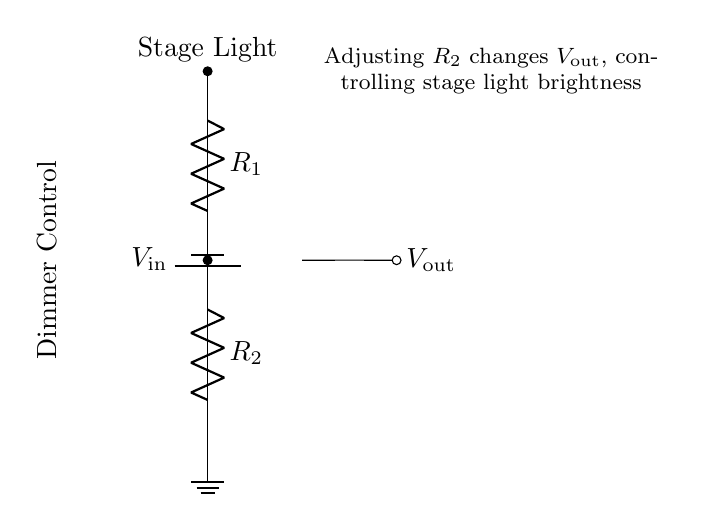What do R1 and R2 represent in this circuit? R1 and R2 are resistors in the voltage divider network, used to divide the input voltage.
Answer: Resistors What is the purpose of the dimmer control? The dimmer control varies the resistance of R2, which in turn changes the output voltage and the brightness of the stage lights.
Answer: Adjusts brightness What is Vout in this circuit? Vout is the voltage across the second resistor R2, which is connected to the stage light. It determines the brightness level of the light.
Answer: Voltage across R2 How does changing R2 affect Vout? Increasing R2 reduces Vout, while decreasing R2 increases Vout, thus controlling the brightness of the stage light.
Answer: It alters brightness What is the function of the battery in this circuit? The battery provides the input voltage to the circuit, which is needed to create the voltage drop across R1 and R2.
Answer: Provides input voltage In what configuration are R1 and R2 connected? R1 and R2 are connected in series within the voltage divider configuration.
Answer: Series What happens when R1 is increased while keeping R2 constant? Increasing R1 raises the overall resistance, reducing the current flowing through the circuit which will lower Vout across R2.
Answer: Reduces output voltage 